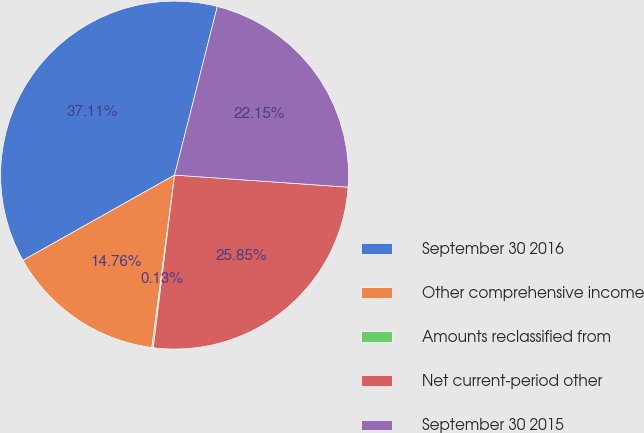Convert chart. <chart><loc_0><loc_0><loc_500><loc_500><pie_chart><fcel>September 30 2016<fcel>Other comprehensive income<fcel>Amounts reclassified from<fcel>Net current-period other<fcel>September 30 2015<nl><fcel>37.11%<fcel>14.76%<fcel>0.13%<fcel>25.85%<fcel>22.15%<nl></chart> 